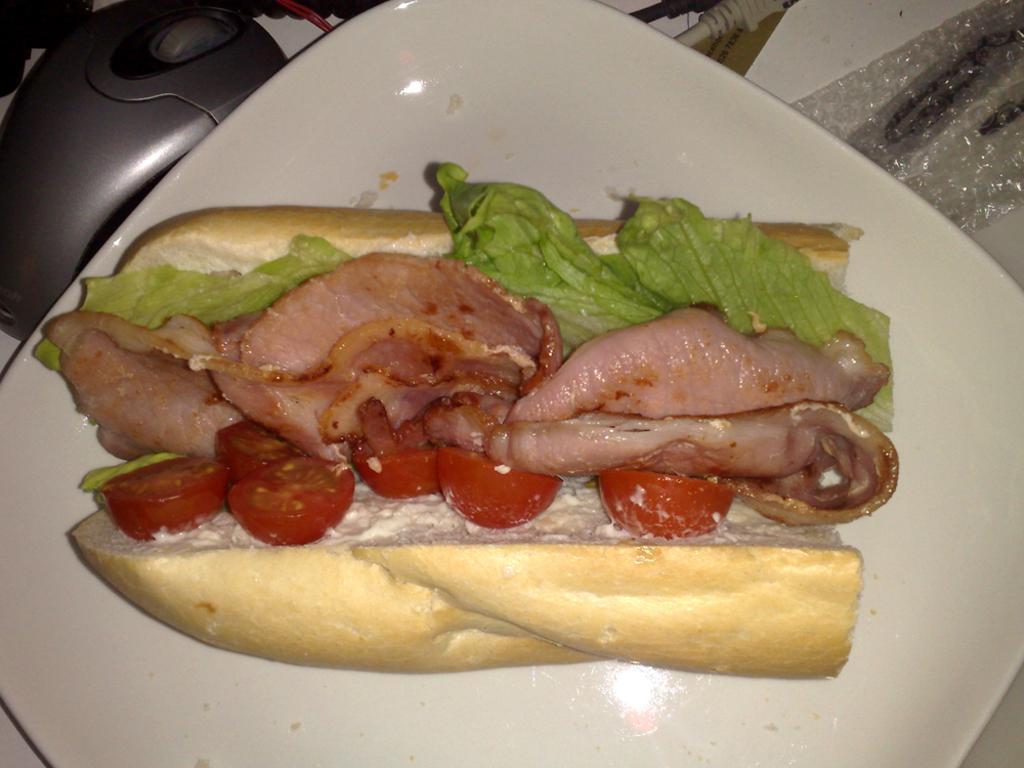What type of food can be seen in the image? There is food in the image, including items on a plate. Can you describe the contents of the plate? The plate contains meat. Is there anything else visible in the image besides the food? Yes, there is a mouse visible in the top left side of the image. What type of fuel is being used by the mouse in the image? There is no fuel present in the image, as it features food and a mouse. The mouse is not using any fuel. 